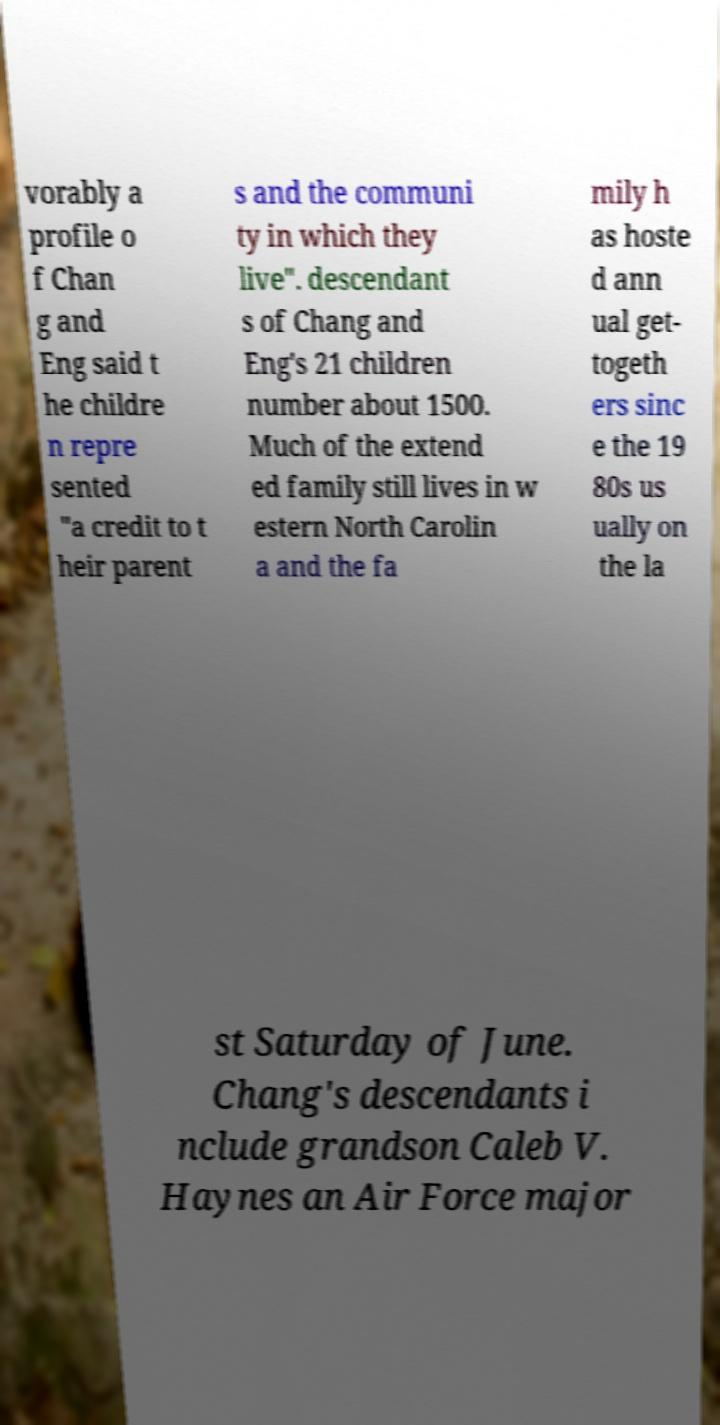For documentation purposes, I need the text within this image transcribed. Could you provide that? vorably a profile o f Chan g and Eng said t he childre n repre sented "a credit to t heir parent s and the communi ty in which they live". descendant s of Chang and Eng's 21 children number about 1500. Much of the extend ed family still lives in w estern North Carolin a and the fa mily h as hoste d ann ual get- togeth ers sinc e the 19 80s us ually on the la st Saturday of June. Chang's descendants i nclude grandson Caleb V. Haynes an Air Force major 